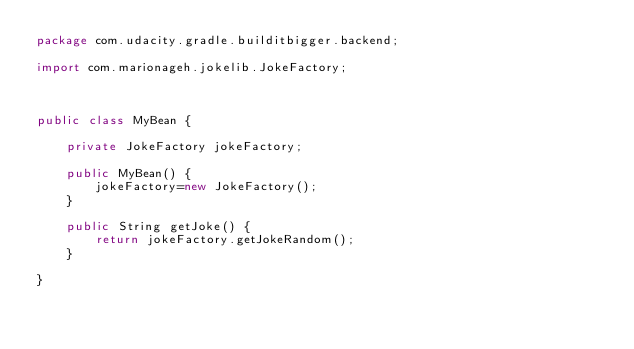<code> <loc_0><loc_0><loc_500><loc_500><_Java_>package com.udacity.gradle.builditbigger.backend;

import com.marionageh.jokelib.JokeFactory;



public class MyBean {

    private JokeFactory jokeFactory;

    public MyBean() {
        jokeFactory=new JokeFactory();
    }

    public String getJoke() {
        return jokeFactory.getJokeRandom();
    }

}</code> 